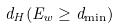Convert formula to latex. <formula><loc_0><loc_0><loc_500><loc_500>d _ { H } ( E _ { w } \geq d _ { \min } )</formula> 